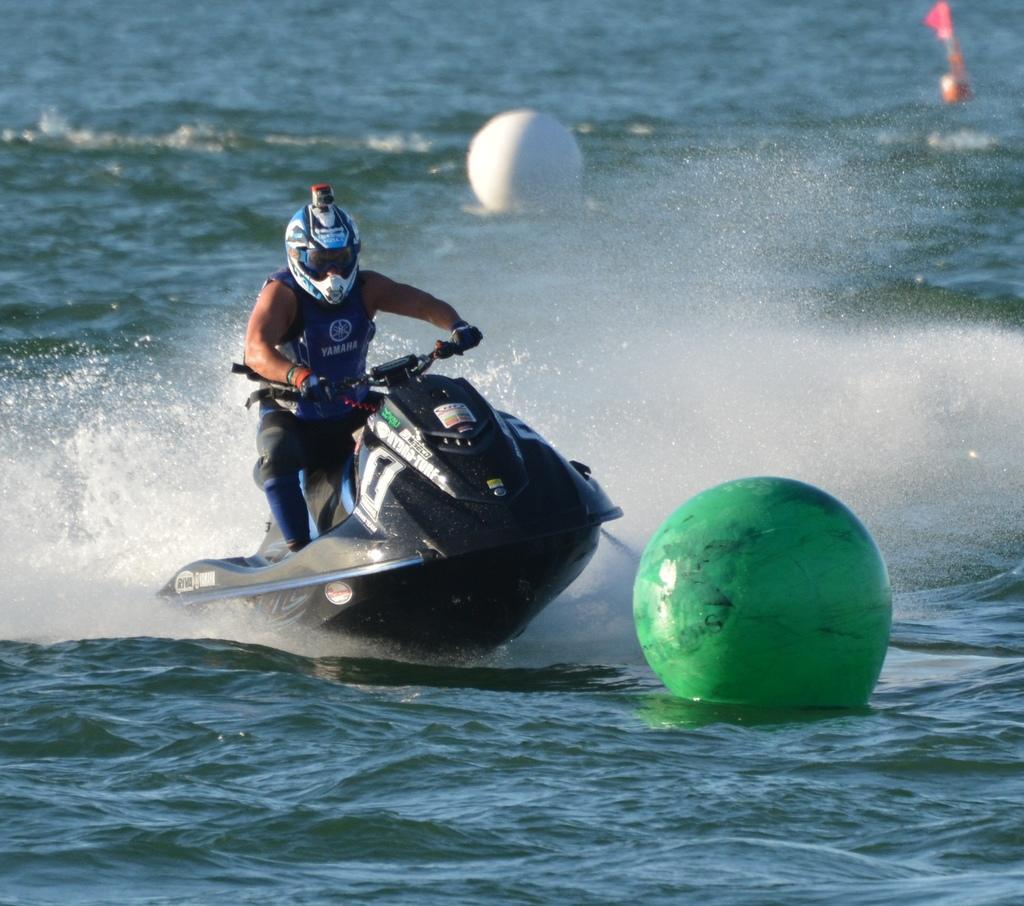In one or two sentences, can you explain what this image depicts? In this image there is water at the bottom. There is a circular object and a small flag on the right corner. There is a person and a jet ski in the foreground. There is water and a circular object in the background. 